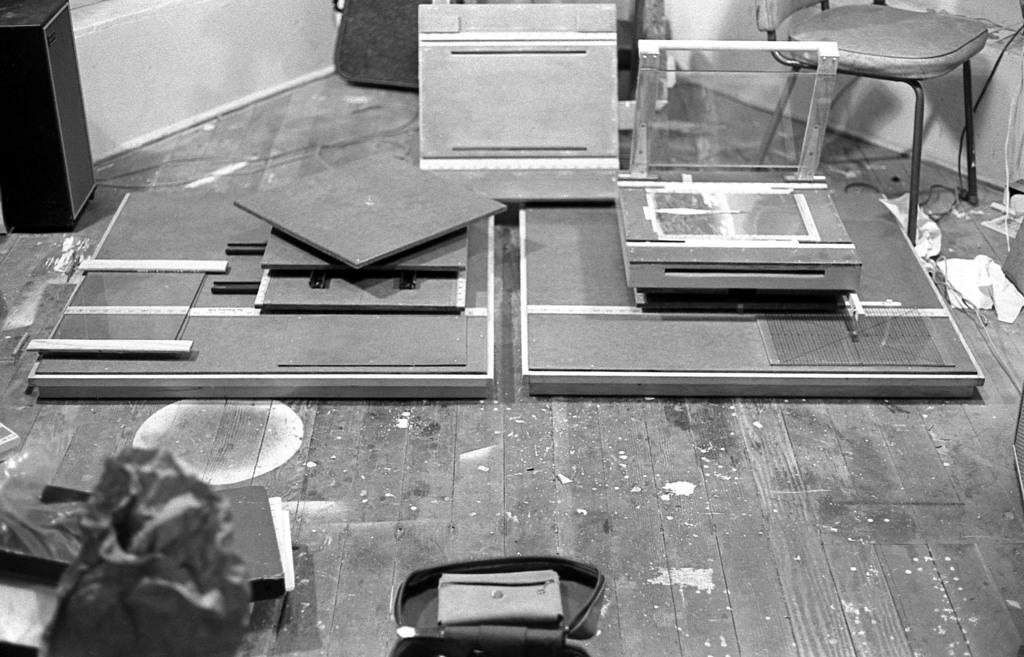What type of flooring is visible in the image? The image has a wooden floor. What object can be seen on the floor? There is a bag on the floor. What piece of furniture is on the floor? There is a chair on the floor. What else is on the floor besides the bag and chair? There are wires on the floor. What is visible in the background of the image? The background of the image includes a wall. What is the tendency of the country in the image? There is no country present in the image, as it only features a wooden floor, a bag, a chair, wires, and a wall in the background. 